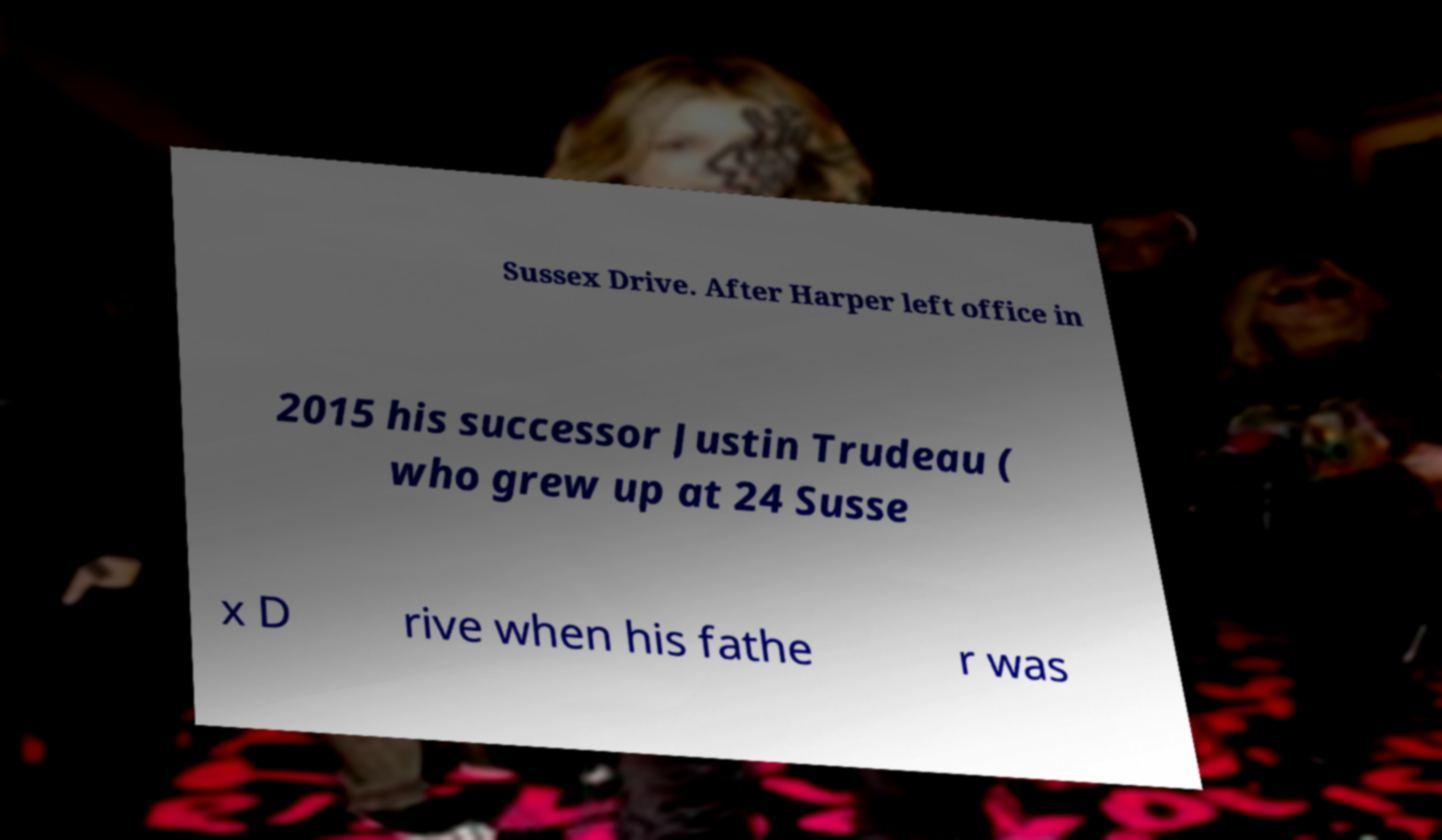Please read and relay the text visible in this image. What does it say? Sussex Drive. After Harper left office in 2015 his successor Justin Trudeau ( who grew up at 24 Susse x D rive when his fathe r was 